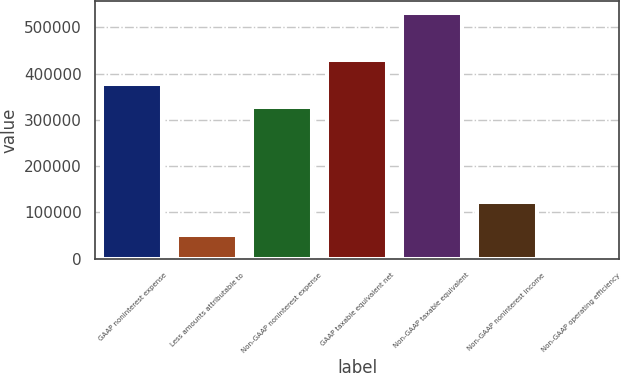Convert chart. <chart><loc_0><loc_0><loc_500><loc_500><bar_chart><fcel>GAAP noninterest expense<fcel>Less amounts attributable to<fcel>Non-GAAP noninterest expense<fcel>GAAP taxable equivalent net<fcel>Non-GAAP taxable equivalent<fcel>Non-GAAP noninterest income<fcel>Non-GAAP operating efficiency<nl><fcel>378018<fcel>50759.7<fcel>327323<fcel>428713<fcel>530104<fcel>122644<fcel>64.56<nl></chart> 